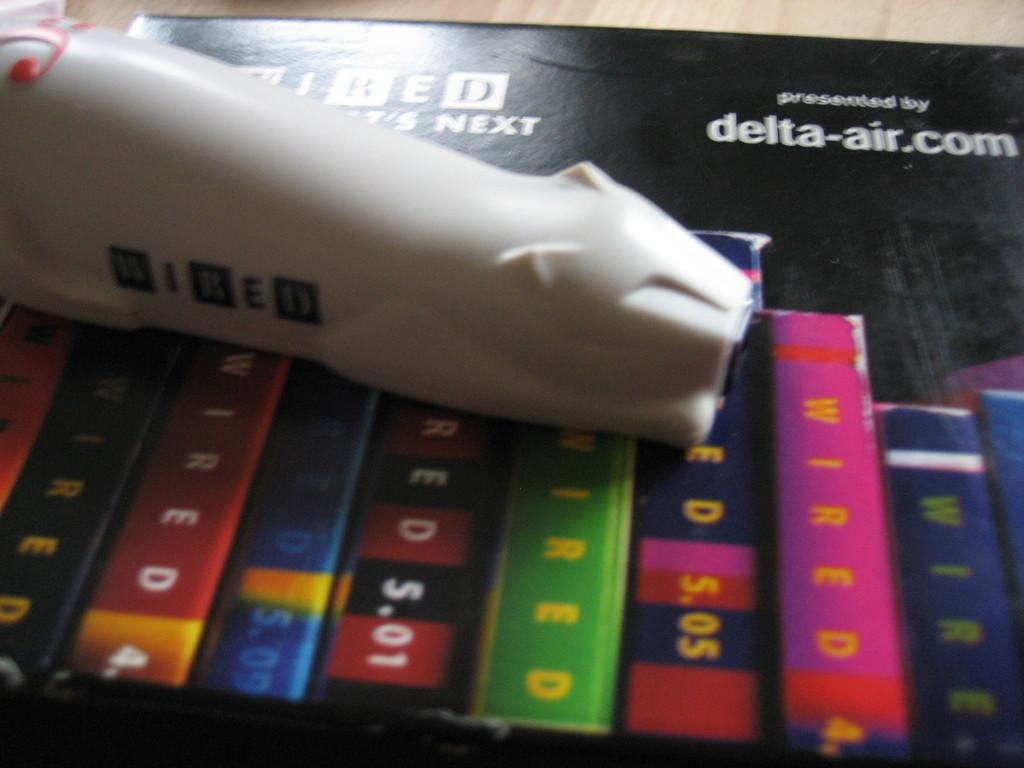<image>
Share a concise interpretation of the image provided. Looks like a flight schedule, it is presented by delta-air.com 